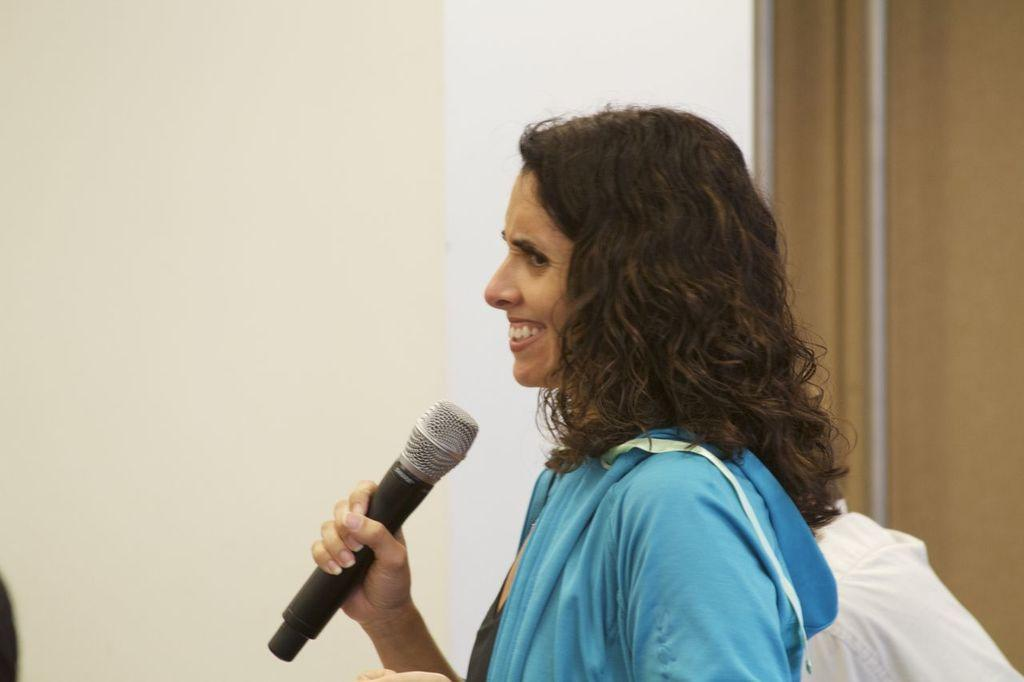Who is the main subject in the image? There is a woman in the image. What is the woman holding in her hand? The woman is holding a mic in her hand. What is the woman's facial expression in the image? The woman is smiling. What can be seen in the background of the image? There is a wall in the background of the image. What type of book is the woman reading in the image? There is no book present in the image; the woman is holding a mic. How many trucks can be seen in the image? There are no trucks present in the image. 